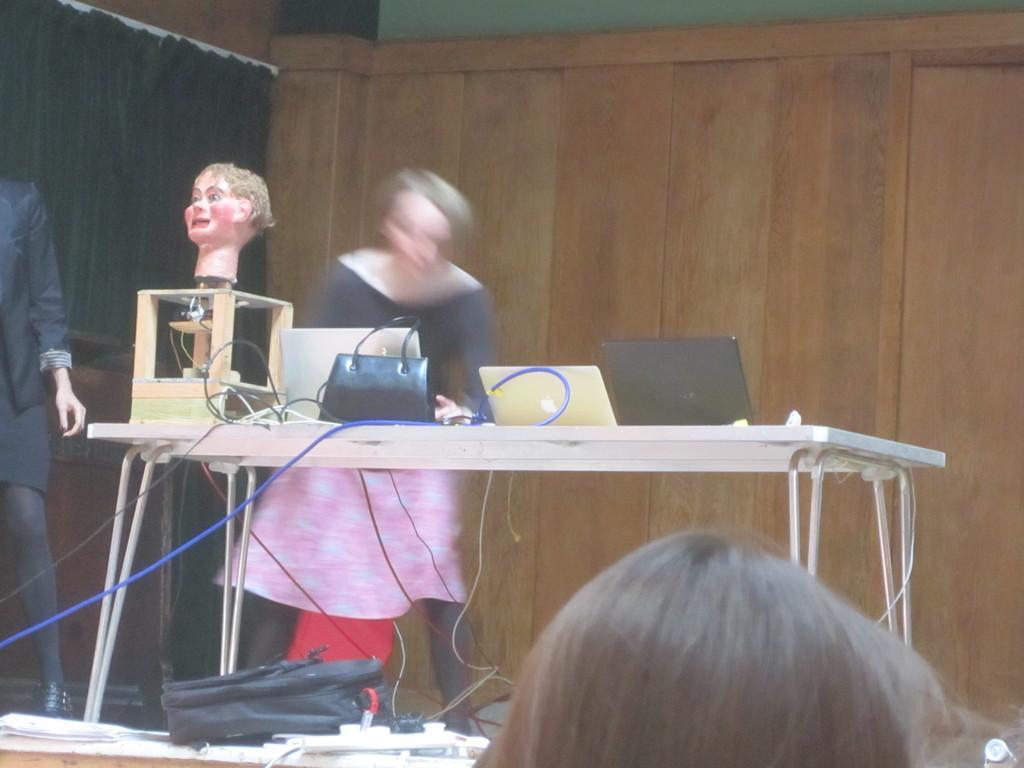Describe this image in one or two sentences. It is a seminar room,there is a table on the stage to the left side of the table a woman is standing ,in front of the table another woman is standing ,on the table there are total three laptops ,a bag and a doll image ,in the background there is a wooden wall. 